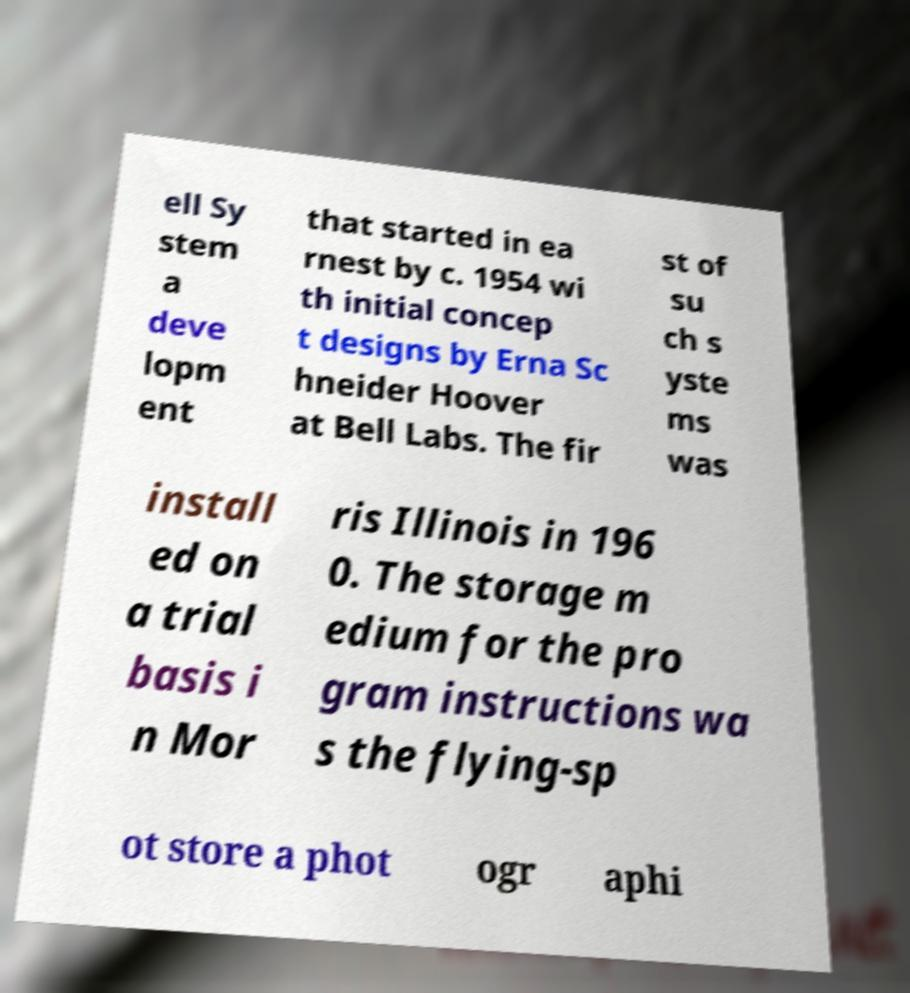Please identify and transcribe the text found in this image. ell Sy stem a deve lopm ent that started in ea rnest by c. 1954 wi th initial concep t designs by Erna Sc hneider Hoover at Bell Labs. The fir st of su ch s yste ms was install ed on a trial basis i n Mor ris Illinois in 196 0. The storage m edium for the pro gram instructions wa s the flying-sp ot store a phot ogr aphi 